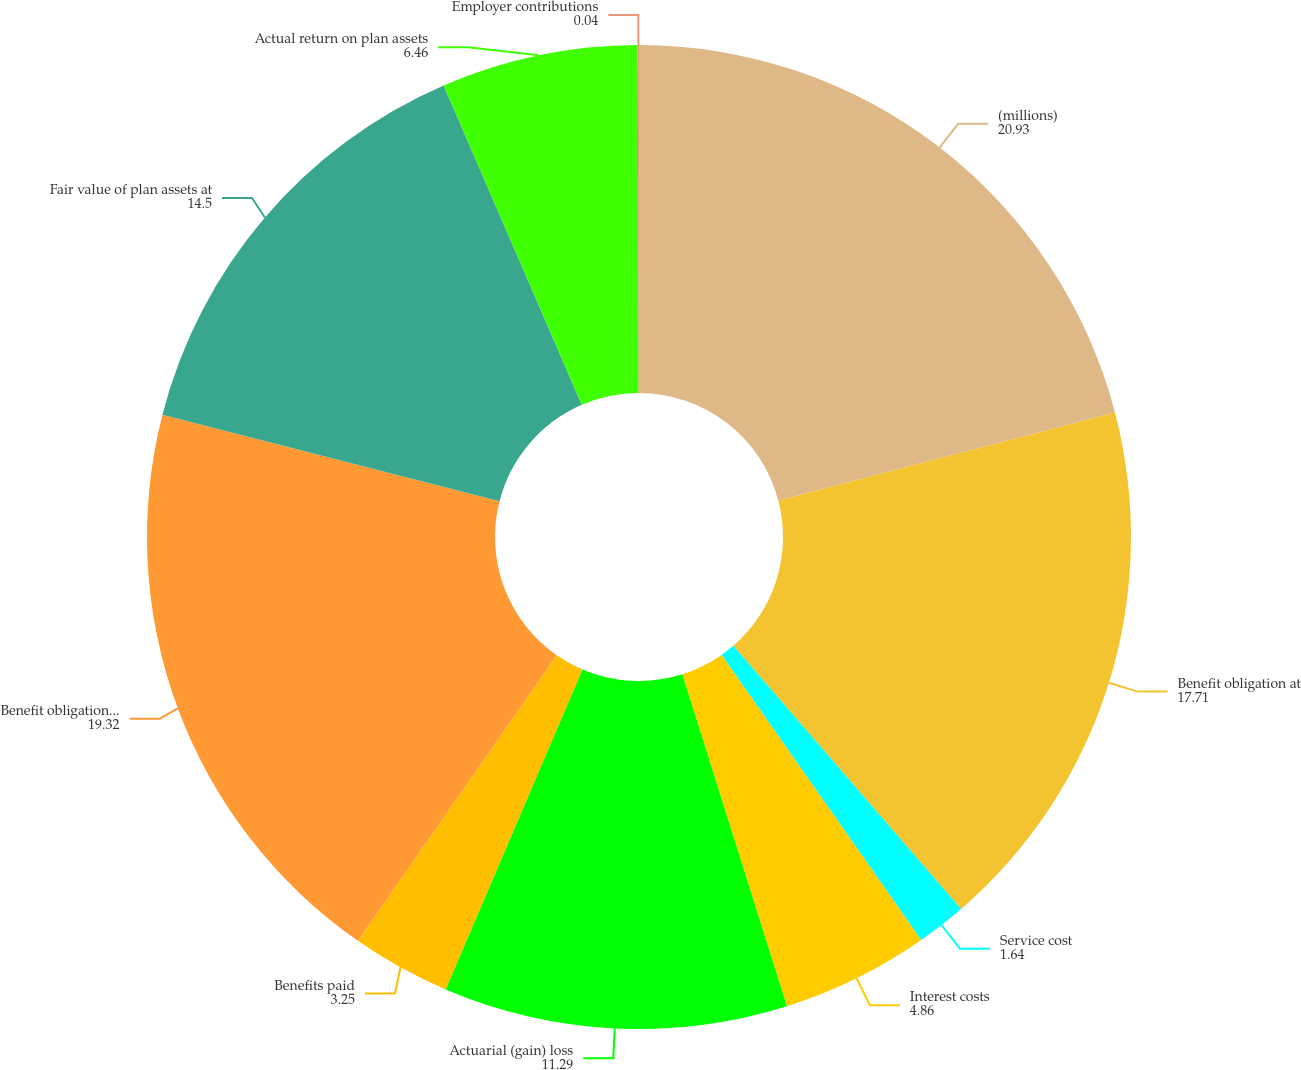<chart> <loc_0><loc_0><loc_500><loc_500><pie_chart><fcel>(millions)<fcel>Benefit obligation at<fcel>Service cost<fcel>Interest costs<fcel>Actuarial (gain) loss<fcel>Benefits paid<fcel>Benefit obligation at end of<fcel>Fair value of plan assets at<fcel>Actual return on plan assets<fcel>Employer contributions<nl><fcel>20.93%<fcel>17.71%<fcel>1.64%<fcel>4.86%<fcel>11.29%<fcel>3.25%<fcel>19.32%<fcel>14.5%<fcel>6.46%<fcel>0.04%<nl></chart> 